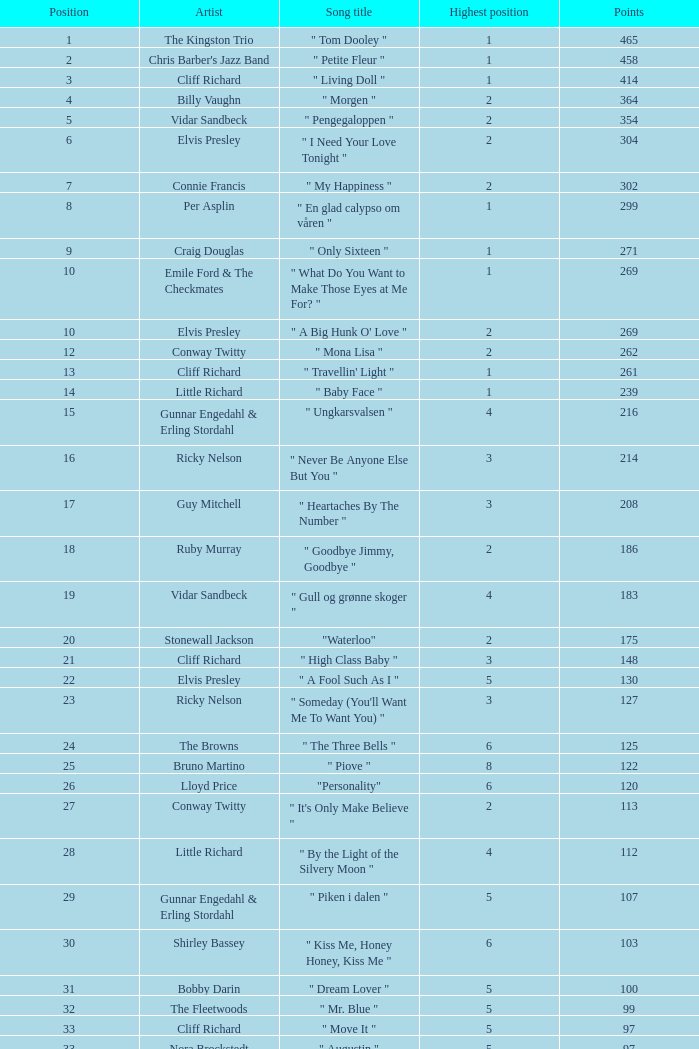Which song was performed by billy vaughn, and what is its name? " Morgen ". Could you help me parse every detail presented in this table? {'header': ['Position', 'Artist', 'Song title', 'Highest position', 'Points'], 'rows': [['1', 'The Kingston Trio', '" Tom Dooley "', '1', '465'], ['2', "Chris Barber's Jazz Band", '" Petite Fleur "', '1', '458'], ['3', 'Cliff Richard', '" Living Doll "', '1', '414'], ['4', 'Billy Vaughn', '" Morgen "', '2', '364'], ['5', 'Vidar Sandbeck', '" Pengegaloppen "', '2', '354'], ['6', 'Elvis Presley', '" I Need Your Love Tonight "', '2', '304'], ['7', 'Connie Francis', '" My Happiness "', '2', '302'], ['8', 'Per Asplin', '" En glad calypso om våren "', '1', '299'], ['9', 'Craig Douglas', '" Only Sixteen "', '1', '271'], ['10', 'Emile Ford & The Checkmates', '" What Do You Want to Make Those Eyes at Me For? "', '1', '269'], ['10', 'Elvis Presley', '" A Big Hunk O\' Love "', '2', '269'], ['12', 'Conway Twitty', '" Mona Lisa "', '2', '262'], ['13', 'Cliff Richard', '" Travellin\' Light "', '1', '261'], ['14', 'Little Richard', '" Baby Face "', '1', '239'], ['15', 'Gunnar Engedahl & Erling Stordahl', '" Ungkarsvalsen "', '4', '216'], ['16', 'Ricky Nelson', '" Never Be Anyone Else But You "', '3', '214'], ['17', 'Guy Mitchell', '" Heartaches By The Number "', '3', '208'], ['18', 'Ruby Murray', '" Goodbye Jimmy, Goodbye "', '2', '186'], ['19', 'Vidar Sandbeck', '" Gull og grønne skoger "', '4', '183'], ['20', 'Stonewall Jackson', '"Waterloo"', '2', '175'], ['21', 'Cliff Richard', '" High Class Baby "', '3', '148'], ['22', 'Elvis Presley', '" A Fool Such As I "', '5', '130'], ['23', 'Ricky Nelson', '" Someday (You\'ll Want Me To Want You) "', '3', '127'], ['24', 'The Browns', '" The Three Bells "', '6', '125'], ['25', 'Bruno Martino', '" Piove "', '8', '122'], ['26', 'Lloyd Price', '"Personality"', '6', '120'], ['27', 'Conway Twitty', '" It\'s Only Make Believe "', '2', '113'], ['28', 'Little Richard', '" By the Light of the Silvery Moon "', '4', '112'], ['29', 'Gunnar Engedahl & Erling Stordahl', '" Piken i dalen "', '5', '107'], ['30', 'Shirley Bassey', '" Kiss Me, Honey Honey, Kiss Me "', '6', '103'], ['31', 'Bobby Darin', '" Dream Lover "', '5', '100'], ['32', 'The Fleetwoods', '" Mr. Blue "', '5', '99'], ['33', 'Cliff Richard', '" Move It "', '5', '97'], ['33', 'Nora Brockstedt', '" Augustin "', '5', '97'], ['35', 'The Coasters', '" Charlie Brown "', '5', '85'], ['36', 'Cliff Richard', '" Never Mind "', '5', '82'], ['37', 'Jerry Keller', '" Here Comes Summer "', '8', '73'], ['38', 'Connie Francis', '" Lipstick On Your Collar "', '7', '80'], ['39', 'Lloyd Price', '" Stagger Lee "', '8', '58'], ['40', 'Floyd Robinson', '" Makin\' Love "', '7', '53'], ['41', 'Jane Morgan', '" The Day The Rains Came "', '7', '49'], ['42', 'Bing Crosby', '" White Christmas "', '6', '41'], ['43', 'Paul Anka', '" Lonely Boy "', '9', '36'], ['44', 'Bobby Darin', '" Mack The Knife "', '9', '34'], ['45', 'Pat Boone', '" I\'ll Remember Tonight "', '9', '23'], ['46', 'Sam Cooke', '" Only Sixteen "', '10', '22'], ['47', 'Bruno Martino', '" Come prima "', '9', '12']]} 